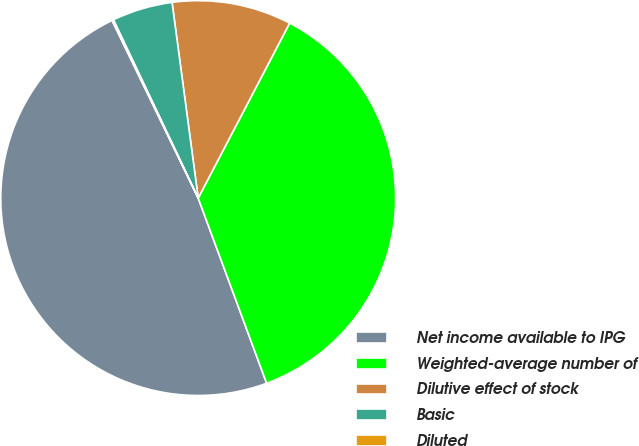<chart> <loc_0><loc_0><loc_500><loc_500><pie_chart><fcel>Net income available to IPG<fcel>Weighted-average number of<fcel>Dilutive effect of stock<fcel>Basic<fcel>Diluted<nl><fcel>48.45%<fcel>36.7%<fcel>9.78%<fcel>4.95%<fcel>0.12%<nl></chart> 